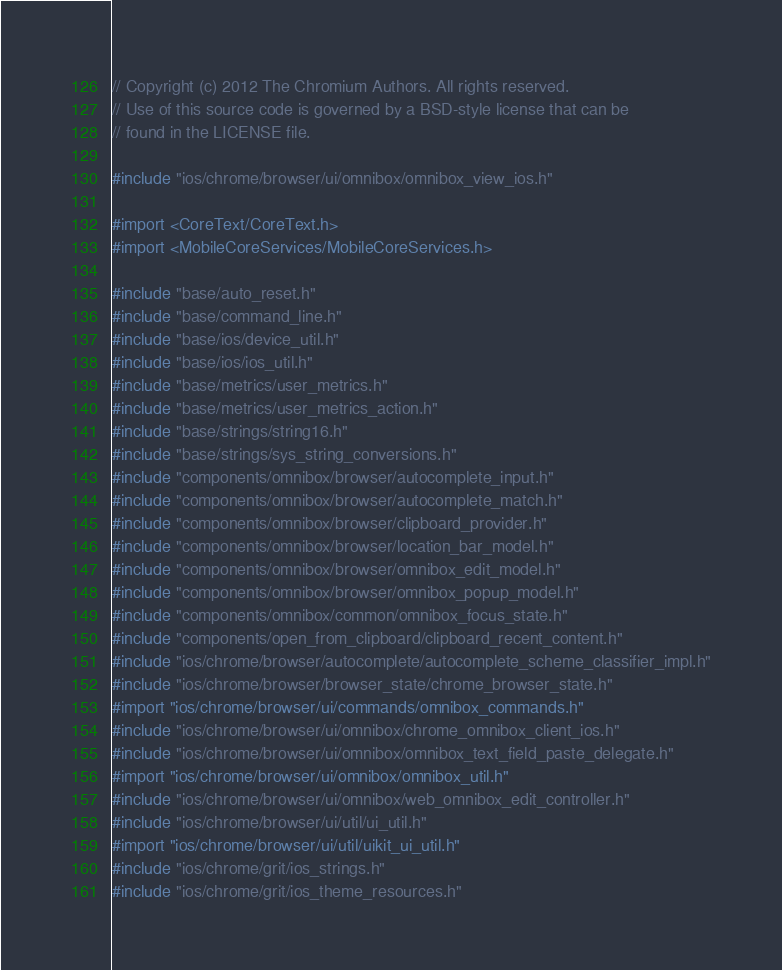Convert code to text. <code><loc_0><loc_0><loc_500><loc_500><_ObjectiveC_>// Copyright (c) 2012 The Chromium Authors. All rights reserved.
// Use of this source code is governed by a BSD-style license that can be
// found in the LICENSE file.

#include "ios/chrome/browser/ui/omnibox/omnibox_view_ios.h"

#import <CoreText/CoreText.h>
#import <MobileCoreServices/MobileCoreServices.h>

#include "base/auto_reset.h"
#include "base/command_line.h"
#include "base/ios/device_util.h"
#include "base/ios/ios_util.h"
#include "base/metrics/user_metrics.h"
#include "base/metrics/user_metrics_action.h"
#include "base/strings/string16.h"
#include "base/strings/sys_string_conversions.h"
#include "components/omnibox/browser/autocomplete_input.h"
#include "components/omnibox/browser/autocomplete_match.h"
#include "components/omnibox/browser/clipboard_provider.h"
#include "components/omnibox/browser/location_bar_model.h"
#include "components/omnibox/browser/omnibox_edit_model.h"
#include "components/omnibox/browser/omnibox_popup_model.h"
#include "components/omnibox/common/omnibox_focus_state.h"
#include "components/open_from_clipboard/clipboard_recent_content.h"
#include "ios/chrome/browser/autocomplete/autocomplete_scheme_classifier_impl.h"
#include "ios/chrome/browser/browser_state/chrome_browser_state.h"
#import "ios/chrome/browser/ui/commands/omnibox_commands.h"
#include "ios/chrome/browser/ui/omnibox/chrome_omnibox_client_ios.h"
#include "ios/chrome/browser/ui/omnibox/omnibox_text_field_paste_delegate.h"
#import "ios/chrome/browser/ui/omnibox/omnibox_util.h"
#include "ios/chrome/browser/ui/omnibox/web_omnibox_edit_controller.h"
#include "ios/chrome/browser/ui/util/ui_util.h"
#import "ios/chrome/browser/ui/util/uikit_ui_util.h"
#include "ios/chrome/grit/ios_strings.h"
#include "ios/chrome/grit/ios_theme_resources.h"</code> 